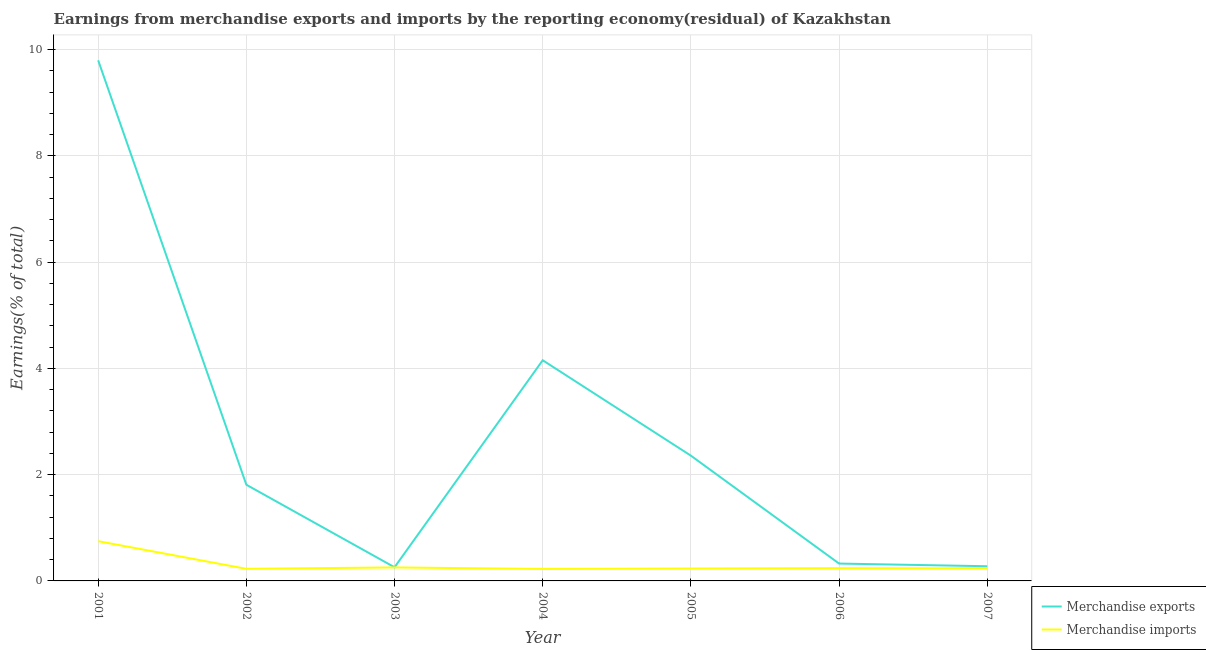How many different coloured lines are there?
Offer a terse response. 2. Does the line corresponding to earnings from merchandise exports intersect with the line corresponding to earnings from merchandise imports?
Your answer should be compact. No. What is the earnings from merchandise exports in 2002?
Make the answer very short. 1.81. Across all years, what is the maximum earnings from merchandise imports?
Keep it short and to the point. 0.75. Across all years, what is the minimum earnings from merchandise imports?
Keep it short and to the point. 0.22. In which year was the earnings from merchandise exports maximum?
Make the answer very short. 2001. In which year was the earnings from merchandise imports minimum?
Provide a short and direct response. 2004. What is the total earnings from merchandise imports in the graph?
Your response must be concise. 2.16. What is the difference between the earnings from merchandise exports in 2002 and that in 2006?
Offer a very short reply. 1.48. What is the difference between the earnings from merchandise imports in 2007 and the earnings from merchandise exports in 2005?
Provide a short and direct response. -2.12. What is the average earnings from merchandise imports per year?
Offer a very short reply. 0.31. In the year 2001, what is the difference between the earnings from merchandise imports and earnings from merchandise exports?
Your answer should be very brief. -9.05. What is the ratio of the earnings from merchandise exports in 2005 to that in 2007?
Make the answer very short. 8.52. Is the difference between the earnings from merchandise exports in 2001 and 2002 greater than the difference between the earnings from merchandise imports in 2001 and 2002?
Offer a very short reply. Yes. What is the difference between the highest and the second highest earnings from merchandise imports?
Keep it short and to the point. 0.49. What is the difference between the highest and the lowest earnings from merchandise imports?
Make the answer very short. 0.52. In how many years, is the earnings from merchandise exports greater than the average earnings from merchandise exports taken over all years?
Ensure brevity in your answer.  2. Does the earnings from merchandise imports monotonically increase over the years?
Offer a very short reply. No. Is the earnings from merchandise exports strictly less than the earnings from merchandise imports over the years?
Your answer should be compact. No. How many years are there in the graph?
Your answer should be compact. 7. What is the difference between two consecutive major ticks on the Y-axis?
Your answer should be compact. 2. Are the values on the major ticks of Y-axis written in scientific E-notation?
Give a very brief answer. No. Where does the legend appear in the graph?
Your response must be concise. Bottom right. What is the title of the graph?
Ensure brevity in your answer.  Earnings from merchandise exports and imports by the reporting economy(residual) of Kazakhstan. Does "National Tourists" appear as one of the legend labels in the graph?
Provide a succinct answer. No. What is the label or title of the Y-axis?
Give a very brief answer. Earnings(% of total). What is the Earnings(% of total) of Merchandise exports in 2001?
Offer a terse response. 9.8. What is the Earnings(% of total) in Merchandise imports in 2001?
Your answer should be compact. 0.75. What is the Earnings(% of total) in Merchandise exports in 2002?
Provide a succinct answer. 1.81. What is the Earnings(% of total) of Merchandise imports in 2002?
Your answer should be compact. 0.23. What is the Earnings(% of total) in Merchandise exports in 2003?
Provide a short and direct response. 0.26. What is the Earnings(% of total) in Merchandise imports in 2003?
Your answer should be very brief. 0.25. What is the Earnings(% of total) of Merchandise exports in 2004?
Offer a very short reply. 4.15. What is the Earnings(% of total) of Merchandise imports in 2004?
Make the answer very short. 0.22. What is the Earnings(% of total) in Merchandise exports in 2005?
Keep it short and to the point. 2.36. What is the Earnings(% of total) in Merchandise imports in 2005?
Your answer should be compact. 0.23. What is the Earnings(% of total) in Merchandise exports in 2006?
Make the answer very short. 0.33. What is the Earnings(% of total) in Merchandise imports in 2006?
Offer a very short reply. 0.24. What is the Earnings(% of total) of Merchandise exports in 2007?
Offer a very short reply. 0.28. What is the Earnings(% of total) of Merchandise imports in 2007?
Make the answer very short. 0.24. Across all years, what is the maximum Earnings(% of total) in Merchandise exports?
Offer a terse response. 9.8. Across all years, what is the maximum Earnings(% of total) in Merchandise imports?
Your answer should be very brief. 0.75. Across all years, what is the minimum Earnings(% of total) in Merchandise exports?
Your answer should be very brief. 0.26. Across all years, what is the minimum Earnings(% of total) of Merchandise imports?
Offer a very short reply. 0.22. What is the total Earnings(% of total) in Merchandise exports in the graph?
Offer a very short reply. 18.98. What is the total Earnings(% of total) of Merchandise imports in the graph?
Keep it short and to the point. 2.16. What is the difference between the Earnings(% of total) of Merchandise exports in 2001 and that in 2002?
Provide a succinct answer. 7.99. What is the difference between the Earnings(% of total) of Merchandise imports in 2001 and that in 2002?
Provide a succinct answer. 0.52. What is the difference between the Earnings(% of total) of Merchandise exports in 2001 and that in 2003?
Your answer should be very brief. 9.54. What is the difference between the Earnings(% of total) in Merchandise imports in 2001 and that in 2003?
Provide a short and direct response. 0.49. What is the difference between the Earnings(% of total) of Merchandise exports in 2001 and that in 2004?
Your response must be concise. 5.64. What is the difference between the Earnings(% of total) in Merchandise imports in 2001 and that in 2004?
Your answer should be compact. 0.52. What is the difference between the Earnings(% of total) of Merchandise exports in 2001 and that in 2005?
Offer a terse response. 7.44. What is the difference between the Earnings(% of total) in Merchandise imports in 2001 and that in 2005?
Provide a succinct answer. 0.51. What is the difference between the Earnings(% of total) of Merchandise exports in 2001 and that in 2006?
Your response must be concise. 9.47. What is the difference between the Earnings(% of total) of Merchandise imports in 2001 and that in 2006?
Keep it short and to the point. 0.51. What is the difference between the Earnings(% of total) of Merchandise exports in 2001 and that in 2007?
Keep it short and to the point. 9.52. What is the difference between the Earnings(% of total) in Merchandise imports in 2001 and that in 2007?
Make the answer very short. 0.51. What is the difference between the Earnings(% of total) in Merchandise exports in 2002 and that in 2003?
Your answer should be compact. 1.55. What is the difference between the Earnings(% of total) of Merchandise imports in 2002 and that in 2003?
Your answer should be compact. -0.03. What is the difference between the Earnings(% of total) in Merchandise exports in 2002 and that in 2004?
Offer a terse response. -2.34. What is the difference between the Earnings(% of total) in Merchandise imports in 2002 and that in 2004?
Provide a succinct answer. 0. What is the difference between the Earnings(% of total) in Merchandise exports in 2002 and that in 2005?
Your answer should be very brief. -0.55. What is the difference between the Earnings(% of total) of Merchandise imports in 2002 and that in 2005?
Your answer should be very brief. -0.01. What is the difference between the Earnings(% of total) in Merchandise exports in 2002 and that in 2006?
Give a very brief answer. 1.48. What is the difference between the Earnings(% of total) of Merchandise imports in 2002 and that in 2006?
Your answer should be compact. -0.01. What is the difference between the Earnings(% of total) of Merchandise exports in 2002 and that in 2007?
Keep it short and to the point. 1.53. What is the difference between the Earnings(% of total) in Merchandise imports in 2002 and that in 2007?
Offer a terse response. -0.01. What is the difference between the Earnings(% of total) of Merchandise exports in 2003 and that in 2004?
Keep it short and to the point. -3.9. What is the difference between the Earnings(% of total) of Merchandise imports in 2003 and that in 2004?
Your answer should be very brief. 0.03. What is the difference between the Earnings(% of total) in Merchandise exports in 2003 and that in 2005?
Offer a very short reply. -2.1. What is the difference between the Earnings(% of total) of Merchandise imports in 2003 and that in 2005?
Offer a very short reply. 0.02. What is the difference between the Earnings(% of total) of Merchandise exports in 2003 and that in 2006?
Give a very brief answer. -0.07. What is the difference between the Earnings(% of total) in Merchandise imports in 2003 and that in 2006?
Your answer should be very brief. 0.01. What is the difference between the Earnings(% of total) in Merchandise exports in 2003 and that in 2007?
Your response must be concise. -0.02. What is the difference between the Earnings(% of total) in Merchandise imports in 2003 and that in 2007?
Keep it short and to the point. 0.02. What is the difference between the Earnings(% of total) in Merchandise exports in 2004 and that in 2005?
Provide a short and direct response. 1.8. What is the difference between the Earnings(% of total) of Merchandise imports in 2004 and that in 2005?
Offer a terse response. -0.01. What is the difference between the Earnings(% of total) in Merchandise exports in 2004 and that in 2006?
Provide a short and direct response. 3.83. What is the difference between the Earnings(% of total) in Merchandise imports in 2004 and that in 2006?
Offer a very short reply. -0.01. What is the difference between the Earnings(% of total) in Merchandise exports in 2004 and that in 2007?
Your response must be concise. 3.88. What is the difference between the Earnings(% of total) of Merchandise imports in 2004 and that in 2007?
Your response must be concise. -0.01. What is the difference between the Earnings(% of total) in Merchandise exports in 2005 and that in 2006?
Provide a succinct answer. 2.03. What is the difference between the Earnings(% of total) of Merchandise imports in 2005 and that in 2006?
Ensure brevity in your answer.  -0.01. What is the difference between the Earnings(% of total) of Merchandise exports in 2005 and that in 2007?
Keep it short and to the point. 2.08. What is the difference between the Earnings(% of total) of Merchandise imports in 2005 and that in 2007?
Your answer should be compact. -0. What is the difference between the Earnings(% of total) of Merchandise exports in 2006 and that in 2007?
Give a very brief answer. 0.05. What is the difference between the Earnings(% of total) of Merchandise imports in 2006 and that in 2007?
Give a very brief answer. 0. What is the difference between the Earnings(% of total) in Merchandise exports in 2001 and the Earnings(% of total) in Merchandise imports in 2002?
Offer a terse response. 9.57. What is the difference between the Earnings(% of total) of Merchandise exports in 2001 and the Earnings(% of total) of Merchandise imports in 2003?
Your answer should be very brief. 9.54. What is the difference between the Earnings(% of total) of Merchandise exports in 2001 and the Earnings(% of total) of Merchandise imports in 2004?
Provide a short and direct response. 9.57. What is the difference between the Earnings(% of total) in Merchandise exports in 2001 and the Earnings(% of total) in Merchandise imports in 2005?
Provide a succinct answer. 9.56. What is the difference between the Earnings(% of total) in Merchandise exports in 2001 and the Earnings(% of total) in Merchandise imports in 2006?
Make the answer very short. 9.56. What is the difference between the Earnings(% of total) of Merchandise exports in 2001 and the Earnings(% of total) of Merchandise imports in 2007?
Your answer should be very brief. 9.56. What is the difference between the Earnings(% of total) of Merchandise exports in 2002 and the Earnings(% of total) of Merchandise imports in 2003?
Ensure brevity in your answer.  1.56. What is the difference between the Earnings(% of total) in Merchandise exports in 2002 and the Earnings(% of total) in Merchandise imports in 2004?
Your answer should be compact. 1.59. What is the difference between the Earnings(% of total) of Merchandise exports in 2002 and the Earnings(% of total) of Merchandise imports in 2005?
Your response must be concise. 1.58. What is the difference between the Earnings(% of total) in Merchandise exports in 2002 and the Earnings(% of total) in Merchandise imports in 2006?
Give a very brief answer. 1.57. What is the difference between the Earnings(% of total) in Merchandise exports in 2002 and the Earnings(% of total) in Merchandise imports in 2007?
Provide a short and direct response. 1.57. What is the difference between the Earnings(% of total) in Merchandise exports in 2003 and the Earnings(% of total) in Merchandise imports in 2004?
Provide a succinct answer. 0.03. What is the difference between the Earnings(% of total) of Merchandise exports in 2003 and the Earnings(% of total) of Merchandise imports in 2005?
Your answer should be compact. 0.02. What is the difference between the Earnings(% of total) in Merchandise exports in 2003 and the Earnings(% of total) in Merchandise imports in 2006?
Offer a very short reply. 0.02. What is the difference between the Earnings(% of total) in Merchandise exports in 2003 and the Earnings(% of total) in Merchandise imports in 2007?
Provide a succinct answer. 0.02. What is the difference between the Earnings(% of total) of Merchandise exports in 2004 and the Earnings(% of total) of Merchandise imports in 2005?
Your answer should be very brief. 3.92. What is the difference between the Earnings(% of total) of Merchandise exports in 2004 and the Earnings(% of total) of Merchandise imports in 2006?
Give a very brief answer. 3.91. What is the difference between the Earnings(% of total) in Merchandise exports in 2004 and the Earnings(% of total) in Merchandise imports in 2007?
Provide a short and direct response. 3.92. What is the difference between the Earnings(% of total) in Merchandise exports in 2005 and the Earnings(% of total) in Merchandise imports in 2006?
Provide a succinct answer. 2.12. What is the difference between the Earnings(% of total) of Merchandise exports in 2005 and the Earnings(% of total) of Merchandise imports in 2007?
Your answer should be compact. 2.12. What is the difference between the Earnings(% of total) of Merchandise exports in 2006 and the Earnings(% of total) of Merchandise imports in 2007?
Offer a terse response. 0.09. What is the average Earnings(% of total) of Merchandise exports per year?
Offer a terse response. 2.71. What is the average Earnings(% of total) of Merchandise imports per year?
Your answer should be compact. 0.31. In the year 2001, what is the difference between the Earnings(% of total) of Merchandise exports and Earnings(% of total) of Merchandise imports?
Provide a short and direct response. 9.05. In the year 2002, what is the difference between the Earnings(% of total) of Merchandise exports and Earnings(% of total) of Merchandise imports?
Keep it short and to the point. 1.58. In the year 2003, what is the difference between the Earnings(% of total) in Merchandise exports and Earnings(% of total) in Merchandise imports?
Give a very brief answer. 0. In the year 2004, what is the difference between the Earnings(% of total) in Merchandise exports and Earnings(% of total) in Merchandise imports?
Your response must be concise. 3.93. In the year 2005, what is the difference between the Earnings(% of total) of Merchandise exports and Earnings(% of total) of Merchandise imports?
Ensure brevity in your answer.  2.12. In the year 2006, what is the difference between the Earnings(% of total) in Merchandise exports and Earnings(% of total) in Merchandise imports?
Make the answer very short. 0.09. In the year 2007, what is the difference between the Earnings(% of total) in Merchandise exports and Earnings(% of total) in Merchandise imports?
Keep it short and to the point. 0.04. What is the ratio of the Earnings(% of total) in Merchandise exports in 2001 to that in 2002?
Your response must be concise. 5.41. What is the ratio of the Earnings(% of total) in Merchandise imports in 2001 to that in 2002?
Your response must be concise. 3.29. What is the ratio of the Earnings(% of total) of Merchandise exports in 2001 to that in 2003?
Your answer should be compact. 38.11. What is the ratio of the Earnings(% of total) in Merchandise imports in 2001 to that in 2003?
Your response must be concise. 2.94. What is the ratio of the Earnings(% of total) of Merchandise exports in 2001 to that in 2004?
Your answer should be compact. 2.36. What is the ratio of the Earnings(% of total) in Merchandise imports in 2001 to that in 2004?
Provide a short and direct response. 3.33. What is the ratio of the Earnings(% of total) of Merchandise exports in 2001 to that in 2005?
Offer a terse response. 4.16. What is the ratio of the Earnings(% of total) in Merchandise imports in 2001 to that in 2005?
Your answer should be very brief. 3.2. What is the ratio of the Earnings(% of total) of Merchandise exports in 2001 to that in 2006?
Give a very brief answer. 30. What is the ratio of the Earnings(% of total) of Merchandise imports in 2001 to that in 2006?
Offer a very short reply. 3.12. What is the ratio of the Earnings(% of total) of Merchandise exports in 2001 to that in 2007?
Keep it short and to the point. 35.43. What is the ratio of the Earnings(% of total) of Merchandise imports in 2001 to that in 2007?
Your answer should be compact. 3.16. What is the ratio of the Earnings(% of total) of Merchandise exports in 2002 to that in 2003?
Your response must be concise. 7.04. What is the ratio of the Earnings(% of total) in Merchandise imports in 2002 to that in 2003?
Make the answer very short. 0.9. What is the ratio of the Earnings(% of total) of Merchandise exports in 2002 to that in 2004?
Provide a short and direct response. 0.44. What is the ratio of the Earnings(% of total) in Merchandise imports in 2002 to that in 2004?
Ensure brevity in your answer.  1.01. What is the ratio of the Earnings(% of total) in Merchandise exports in 2002 to that in 2005?
Give a very brief answer. 0.77. What is the ratio of the Earnings(% of total) in Merchandise imports in 2002 to that in 2005?
Give a very brief answer. 0.97. What is the ratio of the Earnings(% of total) in Merchandise exports in 2002 to that in 2006?
Ensure brevity in your answer.  5.54. What is the ratio of the Earnings(% of total) of Merchandise imports in 2002 to that in 2006?
Ensure brevity in your answer.  0.95. What is the ratio of the Earnings(% of total) of Merchandise exports in 2002 to that in 2007?
Your answer should be compact. 6.55. What is the ratio of the Earnings(% of total) of Merchandise imports in 2002 to that in 2007?
Make the answer very short. 0.96. What is the ratio of the Earnings(% of total) in Merchandise exports in 2003 to that in 2004?
Your response must be concise. 0.06. What is the ratio of the Earnings(% of total) of Merchandise imports in 2003 to that in 2004?
Keep it short and to the point. 1.13. What is the ratio of the Earnings(% of total) in Merchandise exports in 2003 to that in 2005?
Offer a terse response. 0.11. What is the ratio of the Earnings(% of total) of Merchandise imports in 2003 to that in 2005?
Offer a terse response. 1.09. What is the ratio of the Earnings(% of total) of Merchandise exports in 2003 to that in 2006?
Your answer should be compact. 0.79. What is the ratio of the Earnings(% of total) of Merchandise imports in 2003 to that in 2006?
Make the answer very short. 1.06. What is the ratio of the Earnings(% of total) of Merchandise exports in 2003 to that in 2007?
Ensure brevity in your answer.  0.93. What is the ratio of the Earnings(% of total) in Merchandise imports in 2003 to that in 2007?
Your answer should be very brief. 1.07. What is the ratio of the Earnings(% of total) of Merchandise exports in 2004 to that in 2005?
Offer a very short reply. 1.76. What is the ratio of the Earnings(% of total) of Merchandise imports in 2004 to that in 2005?
Provide a short and direct response. 0.96. What is the ratio of the Earnings(% of total) in Merchandise exports in 2004 to that in 2006?
Your response must be concise. 12.72. What is the ratio of the Earnings(% of total) in Merchandise imports in 2004 to that in 2006?
Your answer should be compact. 0.94. What is the ratio of the Earnings(% of total) in Merchandise exports in 2004 to that in 2007?
Offer a terse response. 15.02. What is the ratio of the Earnings(% of total) of Merchandise imports in 2004 to that in 2007?
Give a very brief answer. 0.95. What is the ratio of the Earnings(% of total) in Merchandise exports in 2005 to that in 2006?
Give a very brief answer. 7.22. What is the ratio of the Earnings(% of total) of Merchandise imports in 2005 to that in 2006?
Your answer should be compact. 0.97. What is the ratio of the Earnings(% of total) of Merchandise exports in 2005 to that in 2007?
Your response must be concise. 8.52. What is the ratio of the Earnings(% of total) of Merchandise imports in 2005 to that in 2007?
Keep it short and to the point. 0.99. What is the ratio of the Earnings(% of total) in Merchandise exports in 2006 to that in 2007?
Your answer should be compact. 1.18. What is the ratio of the Earnings(% of total) of Merchandise imports in 2006 to that in 2007?
Make the answer very short. 1.01. What is the difference between the highest and the second highest Earnings(% of total) in Merchandise exports?
Make the answer very short. 5.64. What is the difference between the highest and the second highest Earnings(% of total) of Merchandise imports?
Your answer should be compact. 0.49. What is the difference between the highest and the lowest Earnings(% of total) in Merchandise exports?
Offer a terse response. 9.54. What is the difference between the highest and the lowest Earnings(% of total) in Merchandise imports?
Provide a succinct answer. 0.52. 